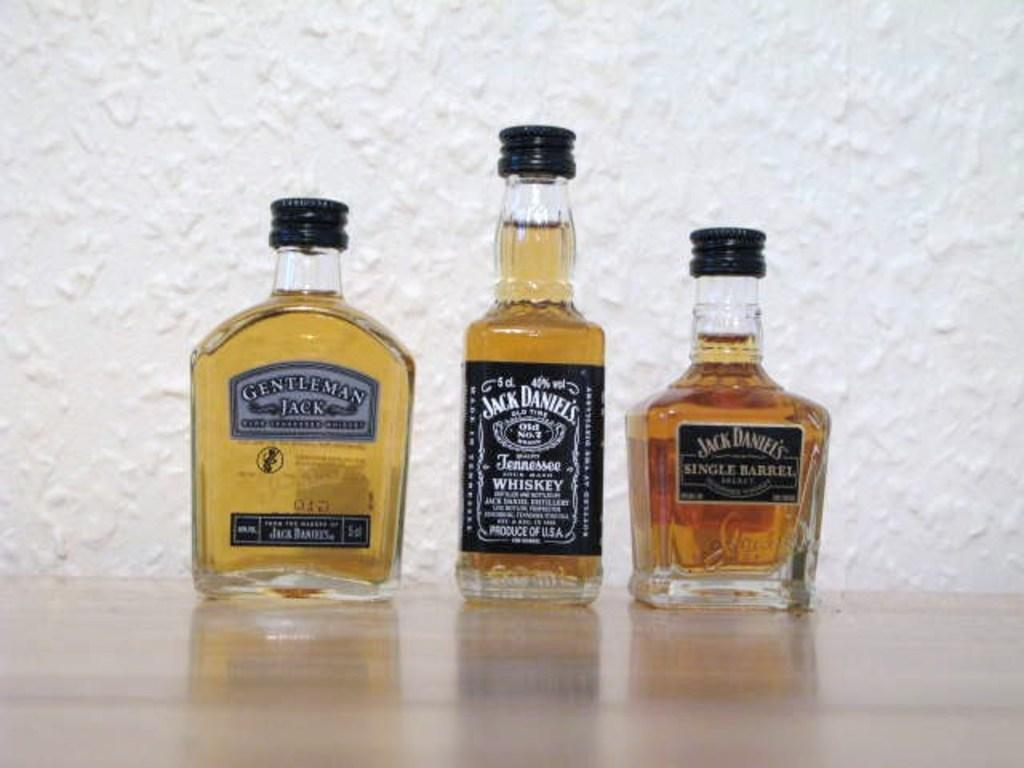How many bottles are on the floor in the image? There are three bottles on the floor in the image. What can be found on the bottles? The bottles have stickers and caps. What can be seen in the background of the image? There is a white color wall in the background. Where is the yak located in the image? There is no yak present in the image. What type of board is being used by the people in the image? There are no people or boards present in the image. 